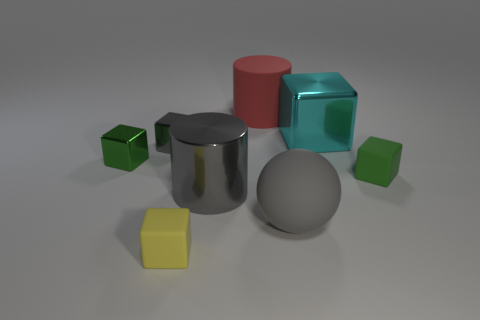Subtract all small gray blocks. How many blocks are left? 4 Add 1 tiny cubes. How many objects exist? 9 Subtract all red cylinders. How many cylinders are left? 1 Subtract 5 cubes. How many cubes are left? 0 Subtract all red cylinders. How many green cubes are left? 2 Add 3 green rubber cubes. How many green rubber cubes are left? 4 Add 7 red cylinders. How many red cylinders exist? 8 Subtract 1 red cylinders. How many objects are left? 7 Subtract all spheres. How many objects are left? 7 Subtract all brown cylinders. Subtract all purple spheres. How many cylinders are left? 2 